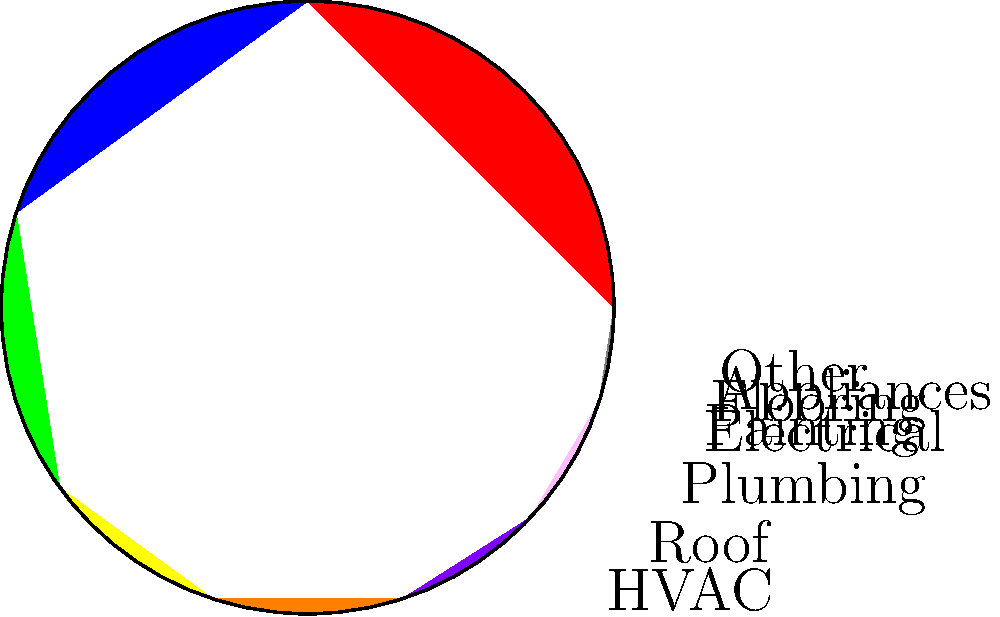As a freelance artist considering homeownership, you're analyzing a pie chart of typical home maintenance expenses. The chart shows that HVAC and roofing costs combined account for 45% of total maintenance expenses. If your estimated annual maintenance budget is $6,000, how much should you set aside for HVAC and roofing costs? To solve this problem, we'll follow these steps:

1. Identify the combined percentage for HVAC and roofing costs from the pie chart:
   HVAC (25%) + Roofing (20%) = 45%

2. Set up the equation to calculate the amount for HVAC and roofing:
   Let x be the amount for HVAC and roofing
   $$\frac{x}{\$6000} = \frac{45}{100}$$

3. Solve the equation:
   $$x = \$6000 \times \frac{45}{100}$$
   $$x = \$6000 \times 0.45$$
   $$x = \$2700$$

4. Round to the nearest dollar if necessary (in this case, it's already a whole number).

Therefore, you should set aside $2,700 for HVAC and roofing costs from your $6,000 annual maintenance budget.
Answer: $2,700 